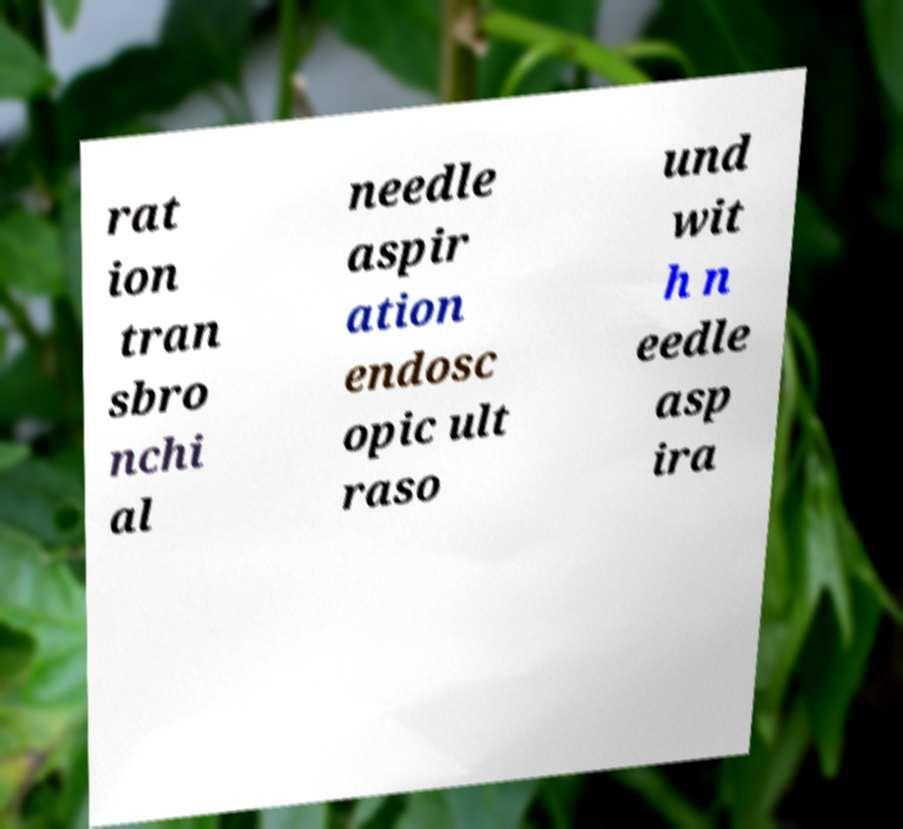Please read and relay the text visible in this image. What does it say? rat ion tran sbro nchi al needle aspir ation endosc opic ult raso und wit h n eedle asp ira 